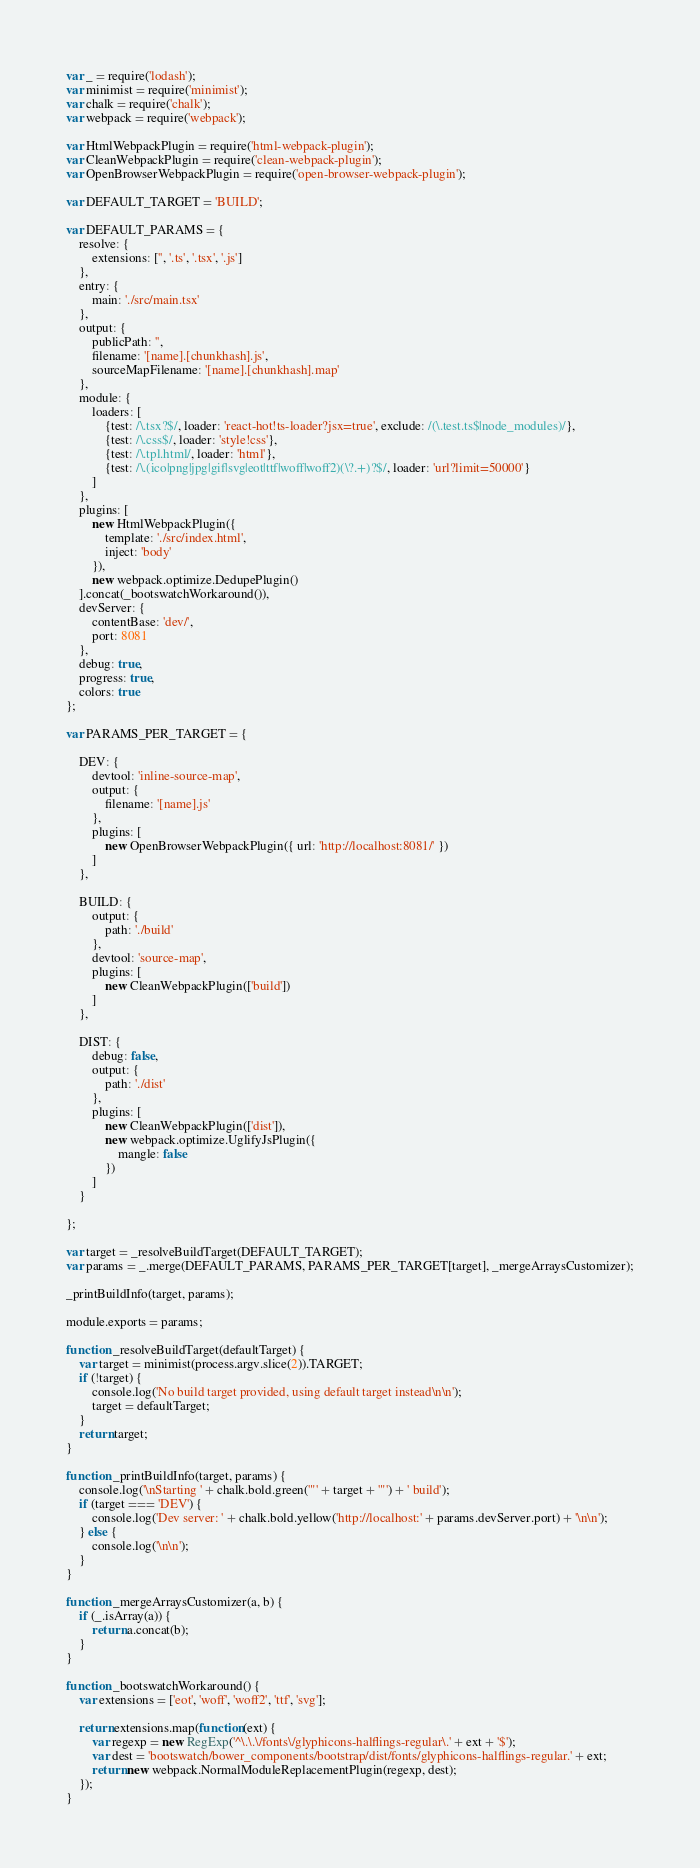<code> <loc_0><loc_0><loc_500><loc_500><_JavaScript_>var _ = require('lodash');
var minimist = require('minimist');
var chalk = require('chalk');
var webpack = require('webpack');

var HtmlWebpackPlugin = require('html-webpack-plugin');
var CleanWebpackPlugin = require('clean-webpack-plugin');
var OpenBrowserWebpackPlugin = require('open-browser-webpack-plugin');

var DEFAULT_TARGET = 'BUILD';

var DEFAULT_PARAMS = {
    resolve: {
        extensions: ['', '.ts', '.tsx', '.js']
    },
    entry: {
        main: './src/main.tsx'
    },
    output: {
        publicPath: '',
        filename: '[name].[chunkhash].js',
        sourceMapFilename: '[name].[chunkhash].map'
    },
    module: {
        loaders: [
            {test: /\.tsx?$/, loader: 'react-hot!ts-loader?jsx=true', exclude: /(\.test.ts$|node_modules)/},
            {test: /\.css$/, loader: 'style!css'},
            {test: /\.tpl.html/, loader: 'html'},
            {test: /\.(ico|png|jpg|gif|svg|eot|ttf|woff|woff2)(\?.+)?$/, loader: 'url?limit=50000'}
        ]
    },
    plugins: [
        new HtmlWebpackPlugin({
            template: './src/index.html',
            inject: 'body'
        }),
        new webpack.optimize.DedupePlugin()
    ].concat(_bootswatchWorkaround()),
    devServer: {
        contentBase: 'dev/',
        port: 8081
    },
    debug: true,
    progress: true,
    colors: true
};

var PARAMS_PER_TARGET = {

    DEV: {
        devtool: 'inline-source-map',
        output: {
            filename: '[name].js'
        },
        plugins: [
            new OpenBrowserWebpackPlugin({ url: 'http://localhost:8081/' })
        ]
    },

    BUILD: {
        output: {
            path: './build'
        },
        devtool: 'source-map',
        plugins: [
            new CleanWebpackPlugin(['build'])
        ]
    },

    DIST: {
        debug: false,
        output: {
            path: './dist'
        },
        plugins: [
            new CleanWebpackPlugin(['dist']),
            new webpack.optimize.UglifyJsPlugin({
                mangle: false
            })
        ]
    }

};

var target = _resolveBuildTarget(DEFAULT_TARGET);
var params = _.merge(DEFAULT_PARAMS, PARAMS_PER_TARGET[target], _mergeArraysCustomizer);

_printBuildInfo(target, params);

module.exports = params;

function _resolveBuildTarget(defaultTarget) {
    var target = minimist(process.argv.slice(2)).TARGET;
    if (!target) {
        console.log('No build target provided, using default target instead\n\n');
        target = defaultTarget;
    }
    return target;
}

function _printBuildInfo(target, params) {
    console.log('\nStarting ' + chalk.bold.green('"' + target + '"') + ' build');
    if (target === 'DEV') {
        console.log('Dev server: ' + chalk.bold.yellow('http://localhost:' + params.devServer.port) + '\n\n');
    } else {
        console.log('\n\n');
    }
}

function _mergeArraysCustomizer(a, b) {
    if (_.isArray(a)) {
        return a.concat(b);
    }
}

function _bootswatchWorkaround() {
	var extensions = ['eot', 'woff', 'woff2', 'ttf', 'svg'];
	
	return extensions.map(function(ext) {
		var regexp = new RegExp('^\.\.\/fonts\/glyphicons-halflings-regular\.' + ext + '$');
		var dest = 'bootswatch/bower_components/bootstrap/dist/fonts/glyphicons-halflings-regular.' + ext;
		return new webpack.NormalModuleReplacementPlugin(regexp, dest);
	});
}
</code> 